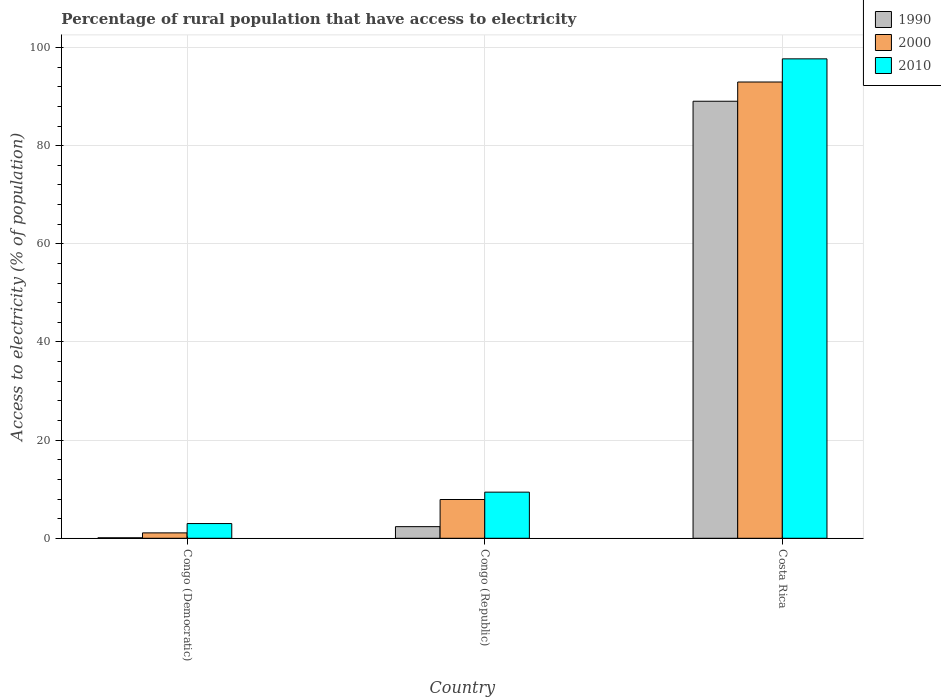How many different coloured bars are there?
Offer a very short reply. 3. How many groups of bars are there?
Keep it short and to the point. 3. Are the number of bars on each tick of the X-axis equal?
Your response must be concise. Yes. How many bars are there on the 2nd tick from the left?
Provide a short and direct response. 3. How many bars are there on the 2nd tick from the right?
Offer a terse response. 3. What is the label of the 2nd group of bars from the left?
Your answer should be very brief. Congo (Republic). In how many cases, is the number of bars for a given country not equal to the number of legend labels?
Your answer should be compact. 0. What is the percentage of rural population that have access to electricity in 1990 in Costa Rica?
Offer a terse response. 89.06. Across all countries, what is the maximum percentage of rural population that have access to electricity in 2010?
Keep it short and to the point. 97.7. Across all countries, what is the minimum percentage of rural population that have access to electricity in 1990?
Keep it short and to the point. 0.1. In which country was the percentage of rural population that have access to electricity in 2010 maximum?
Your answer should be very brief. Costa Rica. In which country was the percentage of rural population that have access to electricity in 2010 minimum?
Give a very brief answer. Congo (Democratic). What is the total percentage of rural population that have access to electricity in 1990 in the graph?
Ensure brevity in your answer.  91.53. What is the difference between the percentage of rural population that have access to electricity in 1990 in Congo (Democratic) and that in Costa Rica?
Provide a short and direct response. -88.96. What is the difference between the percentage of rural population that have access to electricity in 2010 in Congo (Democratic) and the percentage of rural population that have access to electricity in 2000 in Costa Rica?
Give a very brief answer. -89.98. What is the average percentage of rural population that have access to electricity in 1990 per country?
Provide a succinct answer. 30.51. What is the difference between the percentage of rural population that have access to electricity of/in 1990 and percentage of rural population that have access to electricity of/in 2000 in Congo (Democratic)?
Provide a succinct answer. -1. What is the ratio of the percentage of rural population that have access to electricity in 2000 in Congo (Democratic) to that in Congo (Republic)?
Provide a succinct answer. 0.14. Is the difference between the percentage of rural population that have access to electricity in 1990 in Congo (Democratic) and Costa Rica greater than the difference between the percentage of rural population that have access to electricity in 2000 in Congo (Democratic) and Costa Rica?
Provide a short and direct response. Yes. What is the difference between the highest and the second highest percentage of rural population that have access to electricity in 2010?
Your answer should be very brief. 94.7. What is the difference between the highest and the lowest percentage of rural population that have access to electricity in 2010?
Give a very brief answer. 94.7. In how many countries, is the percentage of rural population that have access to electricity in 1990 greater than the average percentage of rural population that have access to electricity in 1990 taken over all countries?
Provide a short and direct response. 1. Is the sum of the percentage of rural population that have access to electricity in 2000 in Congo (Democratic) and Costa Rica greater than the maximum percentage of rural population that have access to electricity in 1990 across all countries?
Keep it short and to the point. Yes. What does the 2nd bar from the right in Costa Rica represents?
Make the answer very short. 2000. How many bars are there?
Ensure brevity in your answer.  9. Are all the bars in the graph horizontal?
Provide a short and direct response. No. How many countries are there in the graph?
Give a very brief answer. 3. What is the difference between two consecutive major ticks on the Y-axis?
Offer a very short reply. 20. Are the values on the major ticks of Y-axis written in scientific E-notation?
Your answer should be very brief. No. Does the graph contain any zero values?
Your answer should be compact. No. Where does the legend appear in the graph?
Keep it short and to the point. Top right. What is the title of the graph?
Provide a succinct answer. Percentage of rural population that have access to electricity. Does "1964" appear as one of the legend labels in the graph?
Provide a short and direct response. No. What is the label or title of the X-axis?
Offer a very short reply. Country. What is the label or title of the Y-axis?
Keep it short and to the point. Access to electricity (% of population). What is the Access to electricity (% of population) in 2000 in Congo (Democratic)?
Keep it short and to the point. 1.1. What is the Access to electricity (% of population) of 1990 in Congo (Republic)?
Your response must be concise. 2.37. What is the Access to electricity (% of population) in 2000 in Congo (Republic)?
Ensure brevity in your answer.  7.9. What is the Access to electricity (% of population) of 1990 in Costa Rica?
Your answer should be very brief. 89.06. What is the Access to electricity (% of population) of 2000 in Costa Rica?
Ensure brevity in your answer.  92.98. What is the Access to electricity (% of population) of 2010 in Costa Rica?
Offer a terse response. 97.7. Across all countries, what is the maximum Access to electricity (% of population) in 1990?
Ensure brevity in your answer.  89.06. Across all countries, what is the maximum Access to electricity (% of population) in 2000?
Your answer should be very brief. 92.98. Across all countries, what is the maximum Access to electricity (% of population) in 2010?
Offer a very short reply. 97.7. Across all countries, what is the minimum Access to electricity (% of population) of 1990?
Your response must be concise. 0.1. Across all countries, what is the minimum Access to electricity (% of population) in 2000?
Keep it short and to the point. 1.1. What is the total Access to electricity (% of population) in 1990 in the graph?
Offer a terse response. 91.53. What is the total Access to electricity (% of population) of 2000 in the graph?
Give a very brief answer. 101.98. What is the total Access to electricity (% of population) of 2010 in the graph?
Your response must be concise. 110.1. What is the difference between the Access to electricity (% of population) of 1990 in Congo (Democratic) and that in Congo (Republic)?
Keep it short and to the point. -2.27. What is the difference between the Access to electricity (% of population) of 2000 in Congo (Democratic) and that in Congo (Republic)?
Ensure brevity in your answer.  -6.8. What is the difference between the Access to electricity (% of population) in 2010 in Congo (Democratic) and that in Congo (Republic)?
Give a very brief answer. -6.4. What is the difference between the Access to electricity (% of population) in 1990 in Congo (Democratic) and that in Costa Rica?
Your response must be concise. -88.96. What is the difference between the Access to electricity (% of population) in 2000 in Congo (Democratic) and that in Costa Rica?
Your answer should be compact. -91.88. What is the difference between the Access to electricity (% of population) of 2010 in Congo (Democratic) and that in Costa Rica?
Offer a terse response. -94.7. What is the difference between the Access to electricity (% of population) of 1990 in Congo (Republic) and that in Costa Rica?
Ensure brevity in your answer.  -86.69. What is the difference between the Access to electricity (% of population) in 2000 in Congo (Republic) and that in Costa Rica?
Keep it short and to the point. -85.08. What is the difference between the Access to electricity (% of population) in 2010 in Congo (Republic) and that in Costa Rica?
Provide a succinct answer. -88.3. What is the difference between the Access to electricity (% of population) of 1990 in Congo (Democratic) and the Access to electricity (% of population) of 2000 in Costa Rica?
Make the answer very short. -92.88. What is the difference between the Access to electricity (% of population) in 1990 in Congo (Democratic) and the Access to electricity (% of population) in 2010 in Costa Rica?
Provide a succinct answer. -97.6. What is the difference between the Access to electricity (% of population) of 2000 in Congo (Democratic) and the Access to electricity (% of population) of 2010 in Costa Rica?
Make the answer very short. -96.6. What is the difference between the Access to electricity (% of population) of 1990 in Congo (Republic) and the Access to electricity (% of population) of 2000 in Costa Rica?
Ensure brevity in your answer.  -90.61. What is the difference between the Access to electricity (% of population) in 1990 in Congo (Republic) and the Access to electricity (% of population) in 2010 in Costa Rica?
Give a very brief answer. -95.33. What is the difference between the Access to electricity (% of population) of 2000 in Congo (Republic) and the Access to electricity (% of population) of 2010 in Costa Rica?
Keep it short and to the point. -89.8. What is the average Access to electricity (% of population) of 1990 per country?
Provide a short and direct response. 30.51. What is the average Access to electricity (% of population) of 2000 per country?
Offer a very short reply. 33.99. What is the average Access to electricity (% of population) in 2010 per country?
Offer a very short reply. 36.7. What is the difference between the Access to electricity (% of population) of 1990 and Access to electricity (% of population) of 2000 in Congo (Democratic)?
Make the answer very short. -1. What is the difference between the Access to electricity (% of population) of 1990 and Access to electricity (% of population) of 2010 in Congo (Democratic)?
Your answer should be very brief. -2.9. What is the difference between the Access to electricity (% of population) of 1990 and Access to electricity (% of population) of 2000 in Congo (Republic)?
Give a very brief answer. -5.53. What is the difference between the Access to electricity (% of population) in 1990 and Access to electricity (% of population) in 2010 in Congo (Republic)?
Offer a terse response. -7.03. What is the difference between the Access to electricity (% of population) of 1990 and Access to electricity (% of population) of 2000 in Costa Rica?
Your response must be concise. -3.92. What is the difference between the Access to electricity (% of population) of 1990 and Access to electricity (% of population) of 2010 in Costa Rica?
Give a very brief answer. -8.64. What is the difference between the Access to electricity (% of population) in 2000 and Access to electricity (% of population) in 2010 in Costa Rica?
Ensure brevity in your answer.  -4.72. What is the ratio of the Access to electricity (% of population) in 1990 in Congo (Democratic) to that in Congo (Republic)?
Keep it short and to the point. 0.04. What is the ratio of the Access to electricity (% of population) of 2000 in Congo (Democratic) to that in Congo (Republic)?
Offer a terse response. 0.14. What is the ratio of the Access to electricity (% of population) of 2010 in Congo (Democratic) to that in Congo (Republic)?
Provide a short and direct response. 0.32. What is the ratio of the Access to electricity (% of population) of 1990 in Congo (Democratic) to that in Costa Rica?
Ensure brevity in your answer.  0. What is the ratio of the Access to electricity (% of population) of 2000 in Congo (Democratic) to that in Costa Rica?
Make the answer very short. 0.01. What is the ratio of the Access to electricity (% of population) of 2010 in Congo (Democratic) to that in Costa Rica?
Offer a very short reply. 0.03. What is the ratio of the Access to electricity (% of population) of 1990 in Congo (Republic) to that in Costa Rica?
Provide a short and direct response. 0.03. What is the ratio of the Access to electricity (% of population) in 2000 in Congo (Republic) to that in Costa Rica?
Keep it short and to the point. 0.09. What is the ratio of the Access to electricity (% of population) of 2010 in Congo (Republic) to that in Costa Rica?
Make the answer very short. 0.1. What is the difference between the highest and the second highest Access to electricity (% of population) of 1990?
Keep it short and to the point. 86.69. What is the difference between the highest and the second highest Access to electricity (% of population) in 2000?
Your answer should be very brief. 85.08. What is the difference between the highest and the second highest Access to electricity (% of population) in 2010?
Offer a terse response. 88.3. What is the difference between the highest and the lowest Access to electricity (% of population) in 1990?
Keep it short and to the point. 88.96. What is the difference between the highest and the lowest Access to electricity (% of population) of 2000?
Your answer should be compact. 91.88. What is the difference between the highest and the lowest Access to electricity (% of population) of 2010?
Ensure brevity in your answer.  94.7. 